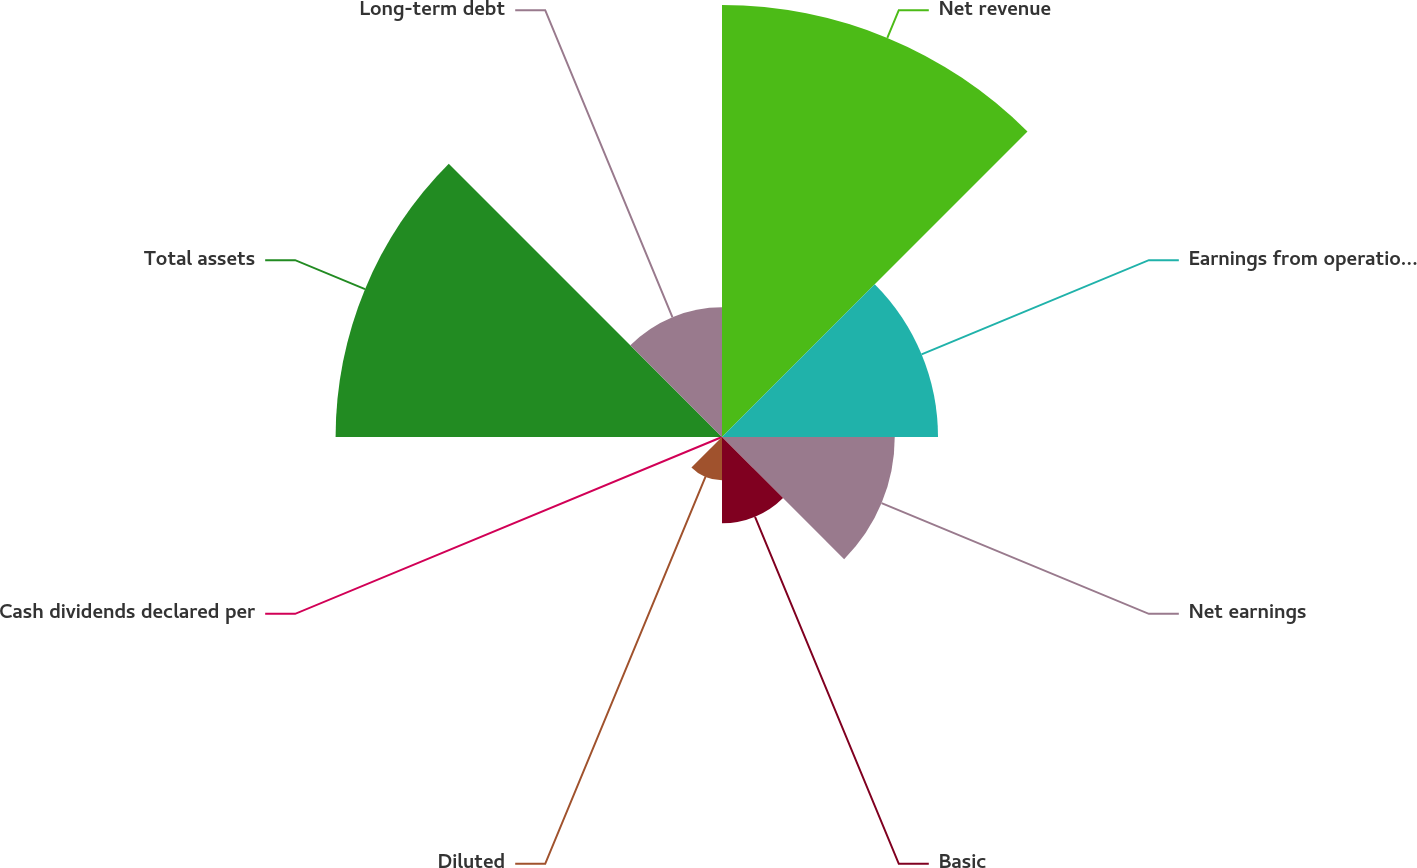Convert chart to OTSL. <chart><loc_0><loc_0><loc_500><loc_500><pie_chart><fcel>Net revenue<fcel>Earnings from operations (1)<fcel>Net earnings<fcel>Basic<fcel>Diluted<fcel>Cash dividends declared per<fcel>Total assets<fcel>Long-term debt<nl><fcel>29.46%<fcel>14.73%<fcel>11.78%<fcel>5.89%<fcel>2.95%<fcel>0.0%<fcel>26.35%<fcel>8.84%<nl></chart> 